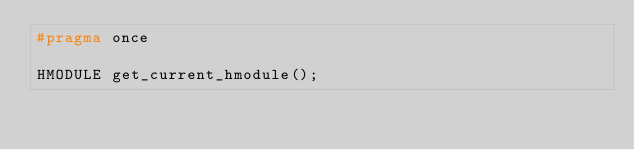Convert code to text. <code><loc_0><loc_0><loc_500><loc_500><_C_>#pragma once

HMODULE get_current_hmodule();</code> 